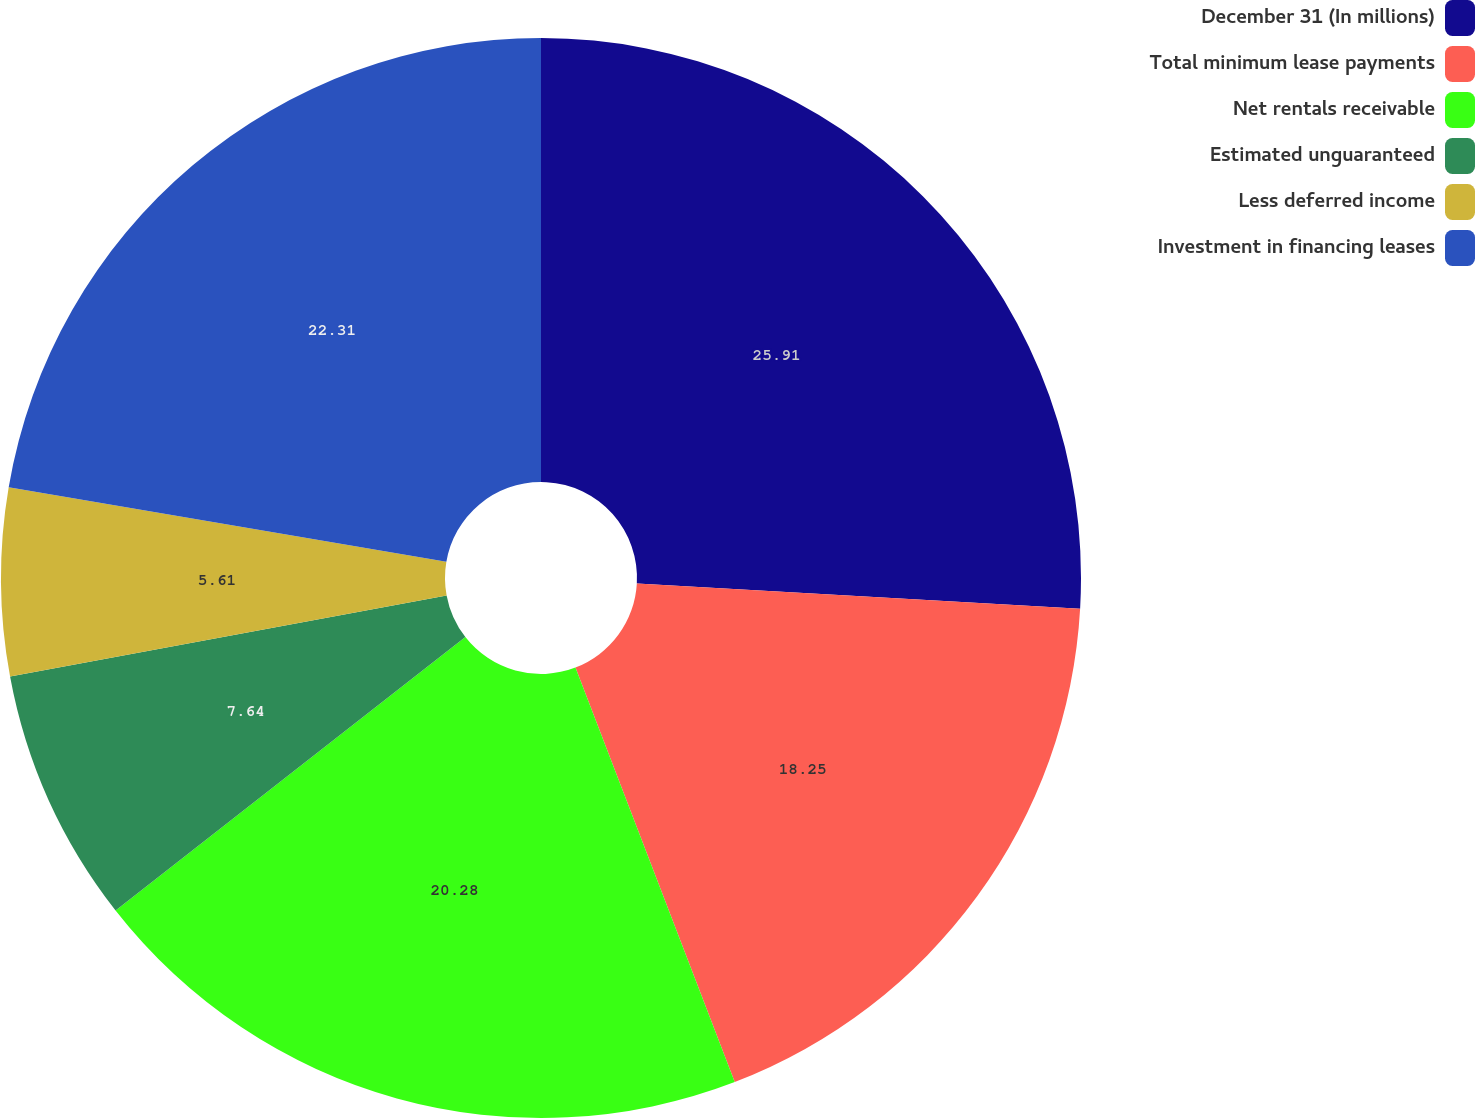Convert chart. <chart><loc_0><loc_0><loc_500><loc_500><pie_chart><fcel>December 31 (In millions)<fcel>Total minimum lease payments<fcel>Net rentals receivable<fcel>Estimated unguaranteed<fcel>Less deferred income<fcel>Investment in financing leases<nl><fcel>25.91%<fcel>18.25%<fcel>20.28%<fcel>7.64%<fcel>5.61%<fcel>22.31%<nl></chart> 